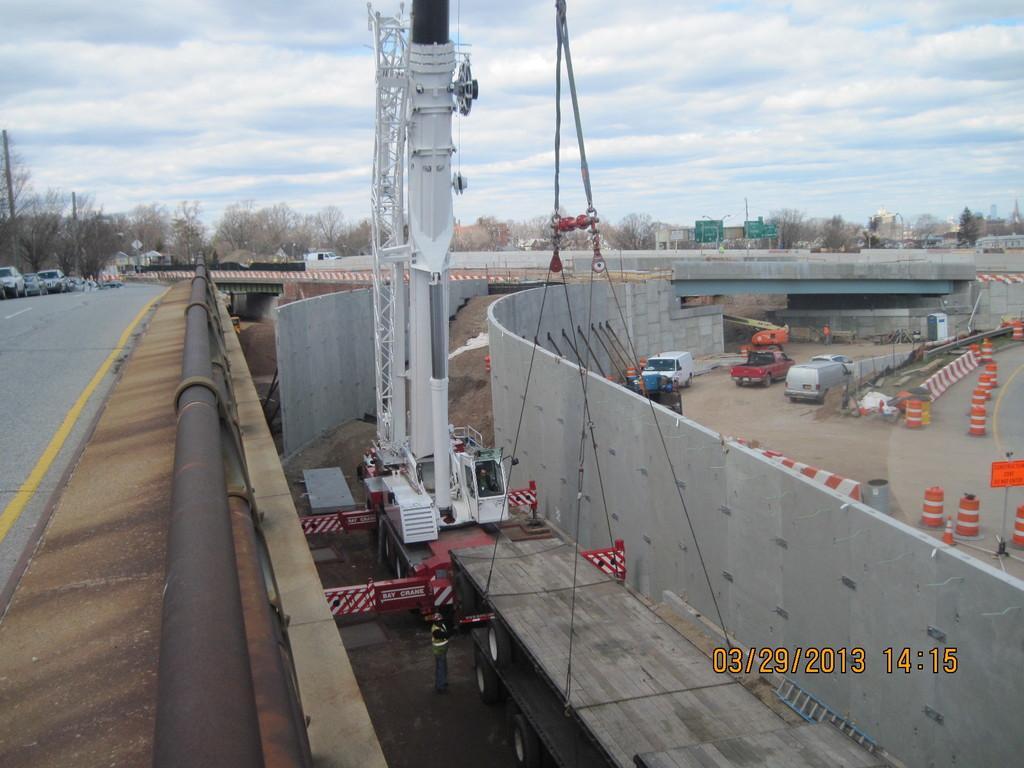Describe this image in one or two sentences. There is a fly over on which, there are vehicles and a pipe which is attached to the fly over. On the right side, there is watermark. In the background, there is a machine which is on the other vehicle near a lorry which is on the road. Beside this lorry, there is a cement wall, there are vehicles on the road, there are barricades, there are trees, buildings and there are clouds in the blue sky. 